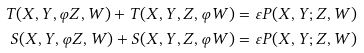Convert formula to latex. <formula><loc_0><loc_0><loc_500><loc_500>T ( X , Y , { \varphi } Z , W ) + T ( X , Y , Z , { \varphi } W ) & = \varepsilon P ( X , Y ; Z , W ) \\ S ( X , Y , { \varphi } Z , W ) + S ( X , Y , Z , { \varphi } W ) & = \varepsilon P ( X , Y ; Z , W )</formula> 